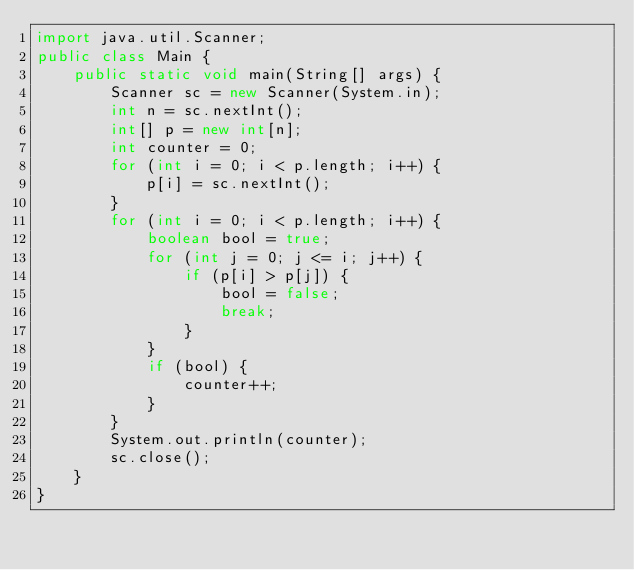<code> <loc_0><loc_0><loc_500><loc_500><_Java_>import java.util.Scanner;
public class Main {
    public static void main(String[] args) {
        Scanner sc = new Scanner(System.in);
        int n = sc.nextInt();
        int[] p = new int[n];
        int counter = 0;
        for (int i = 0; i < p.length; i++) {
            p[i] = sc.nextInt();
        }
        for (int i = 0; i < p.length; i++) {
            boolean bool = true;
            for (int j = 0; j <= i; j++) {
                if (p[i] > p[j]) {
                    bool = false;
                    break;
                }
            }
            if (bool) {
                counter++;
            }
        }
        System.out.println(counter);
        sc.close();
    }
}</code> 